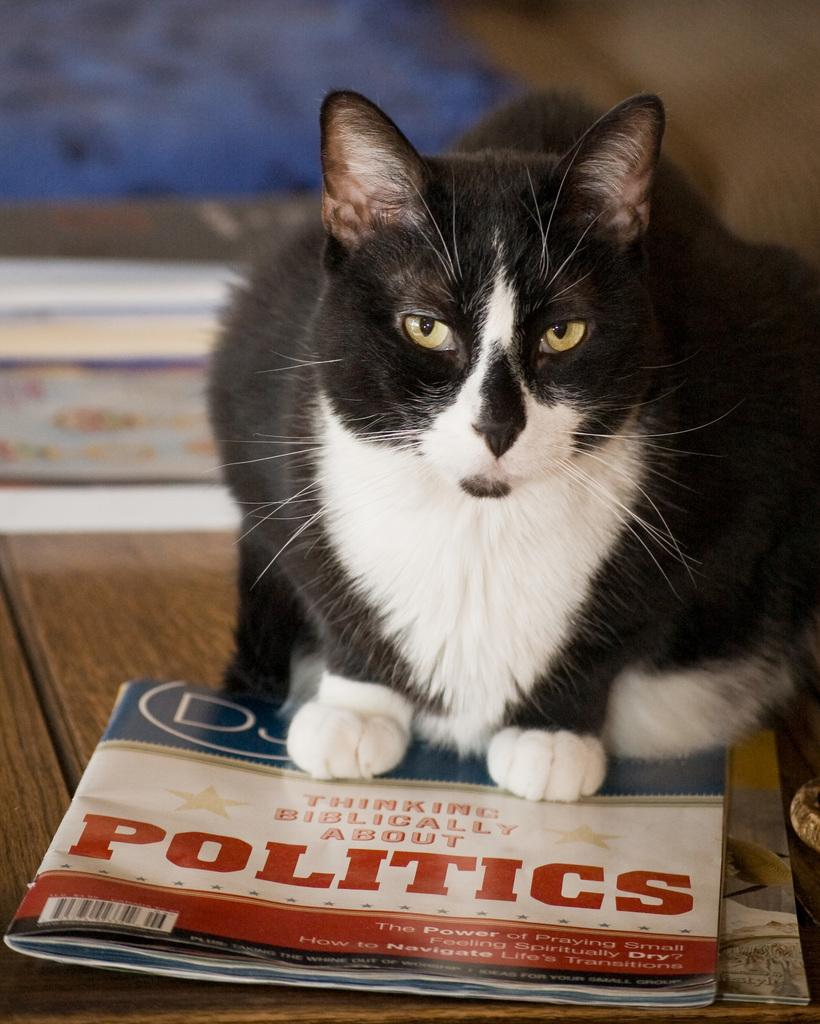<image>
Describe the image concisely. A black, brown and white haired cat sitting on a magazine saying Thinking Biblically About POLITICS 